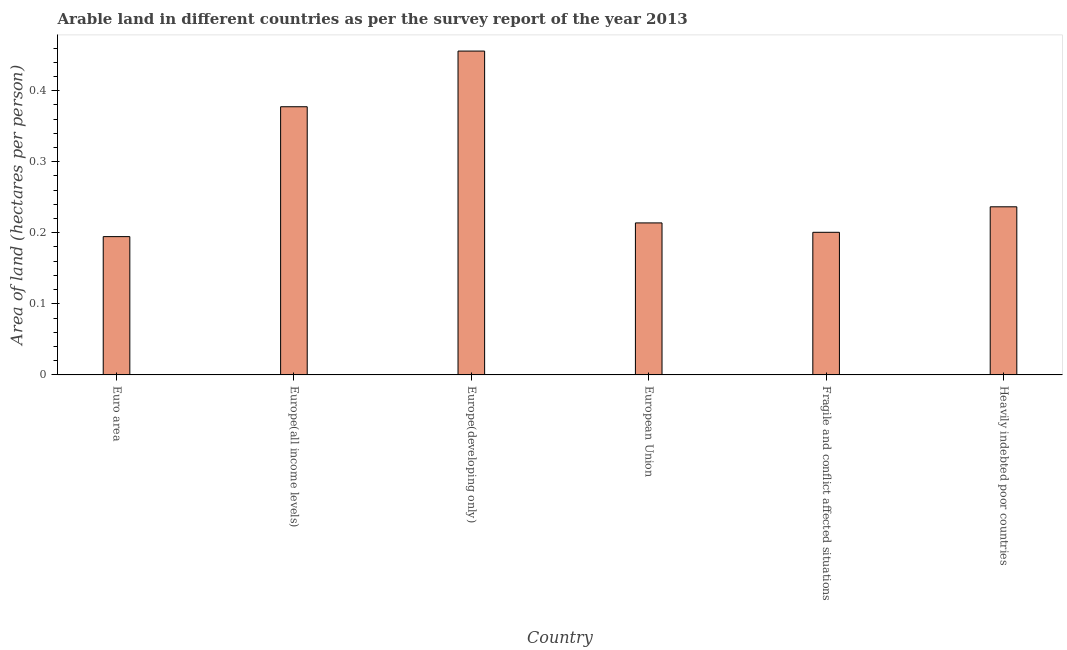Does the graph contain any zero values?
Keep it short and to the point. No. What is the title of the graph?
Provide a succinct answer. Arable land in different countries as per the survey report of the year 2013. What is the label or title of the X-axis?
Ensure brevity in your answer.  Country. What is the label or title of the Y-axis?
Offer a very short reply. Area of land (hectares per person). What is the area of arable land in Heavily indebted poor countries?
Give a very brief answer. 0.24. Across all countries, what is the maximum area of arable land?
Offer a very short reply. 0.46. Across all countries, what is the minimum area of arable land?
Your answer should be compact. 0.19. In which country was the area of arable land maximum?
Provide a short and direct response. Europe(developing only). What is the sum of the area of arable land?
Keep it short and to the point. 1.68. What is the difference between the area of arable land in Europe(developing only) and Heavily indebted poor countries?
Your answer should be compact. 0.22. What is the average area of arable land per country?
Give a very brief answer. 0.28. What is the median area of arable land?
Offer a very short reply. 0.23. What is the ratio of the area of arable land in Europe(all income levels) to that in Fragile and conflict affected situations?
Make the answer very short. 1.88. Is the area of arable land in Europe(all income levels) less than that in Europe(developing only)?
Offer a very short reply. Yes. Is the difference between the area of arable land in Euro area and Heavily indebted poor countries greater than the difference between any two countries?
Ensure brevity in your answer.  No. What is the difference between the highest and the second highest area of arable land?
Offer a terse response. 0.08. What is the difference between the highest and the lowest area of arable land?
Ensure brevity in your answer.  0.26. How many bars are there?
Provide a succinct answer. 6. Are all the bars in the graph horizontal?
Give a very brief answer. No. How many countries are there in the graph?
Offer a very short reply. 6. What is the Area of land (hectares per person) in Euro area?
Your answer should be very brief. 0.19. What is the Area of land (hectares per person) in Europe(all income levels)?
Make the answer very short. 0.38. What is the Area of land (hectares per person) of Europe(developing only)?
Your answer should be compact. 0.46. What is the Area of land (hectares per person) in European Union?
Your answer should be very brief. 0.21. What is the Area of land (hectares per person) in Fragile and conflict affected situations?
Your answer should be compact. 0.2. What is the Area of land (hectares per person) in Heavily indebted poor countries?
Offer a terse response. 0.24. What is the difference between the Area of land (hectares per person) in Euro area and Europe(all income levels)?
Offer a terse response. -0.18. What is the difference between the Area of land (hectares per person) in Euro area and Europe(developing only)?
Provide a short and direct response. -0.26. What is the difference between the Area of land (hectares per person) in Euro area and European Union?
Provide a succinct answer. -0.02. What is the difference between the Area of land (hectares per person) in Euro area and Fragile and conflict affected situations?
Keep it short and to the point. -0.01. What is the difference between the Area of land (hectares per person) in Euro area and Heavily indebted poor countries?
Make the answer very short. -0.04. What is the difference between the Area of land (hectares per person) in Europe(all income levels) and Europe(developing only)?
Make the answer very short. -0.08. What is the difference between the Area of land (hectares per person) in Europe(all income levels) and European Union?
Keep it short and to the point. 0.16. What is the difference between the Area of land (hectares per person) in Europe(all income levels) and Fragile and conflict affected situations?
Your answer should be very brief. 0.18. What is the difference between the Area of land (hectares per person) in Europe(all income levels) and Heavily indebted poor countries?
Ensure brevity in your answer.  0.14. What is the difference between the Area of land (hectares per person) in Europe(developing only) and European Union?
Provide a succinct answer. 0.24. What is the difference between the Area of land (hectares per person) in Europe(developing only) and Fragile and conflict affected situations?
Provide a succinct answer. 0.26. What is the difference between the Area of land (hectares per person) in Europe(developing only) and Heavily indebted poor countries?
Ensure brevity in your answer.  0.22. What is the difference between the Area of land (hectares per person) in European Union and Fragile and conflict affected situations?
Your answer should be compact. 0.01. What is the difference between the Area of land (hectares per person) in European Union and Heavily indebted poor countries?
Ensure brevity in your answer.  -0.02. What is the difference between the Area of land (hectares per person) in Fragile and conflict affected situations and Heavily indebted poor countries?
Provide a succinct answer. -0.04. What is the ratio of the Area of land (hectares per person) in Euro area to that in Europe(all income levels)?
Provide a short and direct response. 0.52. What is the ratio of the Area of land (hectares per person) in Euro area to that in Europe(developing only)?
Provide a short and direct response. 0.43. What is the ratio of the Area of land (hectares per person) in Euro area to that in European Union?
Give a very brief answer. 0.91. What is the ratio of the Area of land (hectares per person) in Euro area to that in Fragile and conflict affected situations?
Ensure brevity in your answer.  0.97. What is the ratio of the Area of land (hectares per person) in Euro area to that in Heavily indebted poor countries?
Make the answer very short. 0.82. What is the ratio of the Area of land (hectares per person) in Europe(all income levels) to that in Europe(developing only)?
Offer a very short reply. 0.83. What is the ratio of the Area of land (hectares per person) in Europe(all income levels) to that in European Union?
Ensure brevity in your answer.  1.76. What is the ratio of the Area of land (hectares per person) in Europe(all income levels) to that in Fragile and conflict affected situations?
Your response must be concise. 1.88. What is the ratio of the Area of land (hectares per person) in Europe(all income levels) to that in Heavily indebted poor countries?
Keep it short and to the point. 1.59. What is the ratio of the Area of land (hectares per person) in Europe(developing only) to that in European Union?
Give a very brief answer. 2.13. What is the ratio of the Area of land (hectares per person) in Europe(developing only) to that in Fragile and conflict affected situations?
Your response must be concise. 2.27. What is the ratio of the Area of land (hectares per person) in Europe(developing only) to that in Heavily indebted poor countries?
Provide a succinct answer. 1.93. What is the ratio of the Area of land (hectares per person) in European Union to that in Fragile and conflict affected situations?
Keep it short and to the point. 1.07. What is the ratio of the Area of land (hectares per person) in European Union to that in Heavily indebted poor countries?
Your answer should be compact. 0.9. What is the ratio of the Area of land (hectares per person) in Fragile and conflict affected situations to that in Heavily indebted poor countries?
Provide a short and direct response. 0.85. 